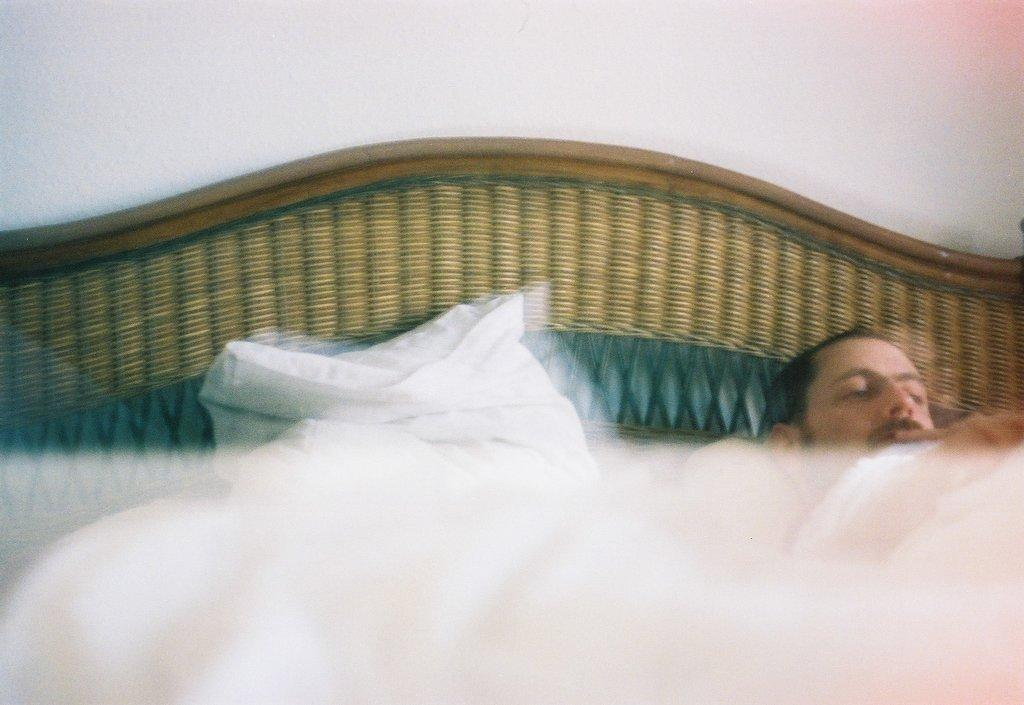What is the main subject of the image? There is a person in the image. What is the person doing in the image? The person is resting on a bed. What can be seen behind the person in the image? There is a wall at the back of the person. How does the person control the credit in the image? There is no mention of credit or any financial aspect in the image, so it is not possible to answer that question. 